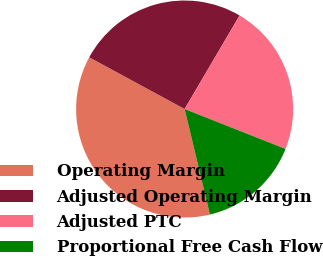<chart> <loc_0><loc_0><loc_500><loc_500><pie_chart><fcel>Operating Margin<fcel>Adjusted Operating Margin<fcel>Adjusted PTC<fcel>Proportional Free Cash Flow<nl><fcel>36.65%<fcel>25.55%<fcel>22.54%<fcel>15.26%<nl></chart> 